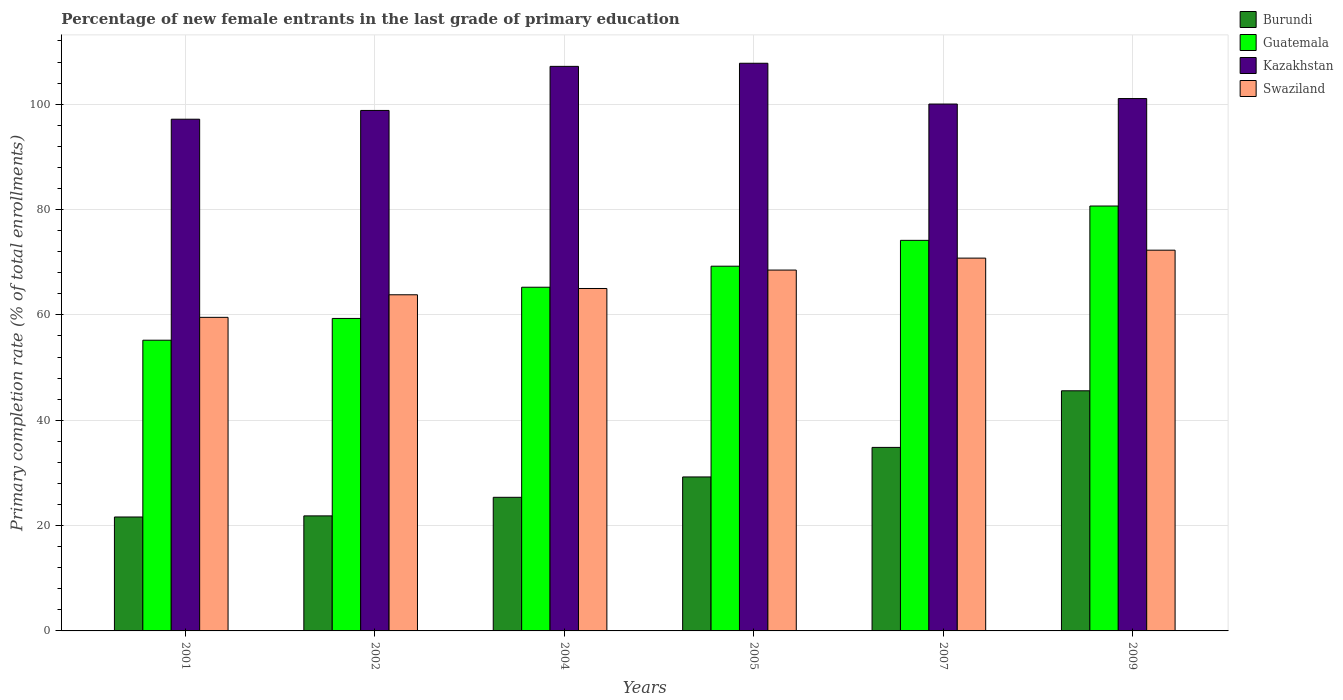How many different coloured bars are there?
Provide a succinct answer. 4. Are the number of bars per tick equal to the number of legend labels?
Your response must be concise. Yes. Are the number of bars on each tick of the X-axis equal?
Provide a succinct answer. Yes. How many bars are there on the 3rd tick from the left?
Your response must be concise. 4. How many bars are there on the 4th tick from the right?
Provide a succinct answer. 4. What is the percentage of new female entrants in Swaziland in 2007?
Offer a terse response. 70.77. Across all years, what is the maximum percentage of new female entrants in Guatemala?
Your answer should be compact. 80.66. Across all years, what is the minimum percentage of new female entrants in Swaziland?
Offer a very short reply. 59.53. In which year was the percentage of new female entrants in Kazakhstan maximum?
Ensure brevity in your answer.  2005. What is the total percentage of new female entrants in Kazakhstan in the graph?
Keep it short and to the point. 611.99. What is the difference between the percentage of new female entrants in Burundi in 2001 and that in 2002?
Make the answer very short. -0.21. What is the difference between the percentage of new female entrants in Burundi in 2005 and the percentage of new female entrants in Guatemala in 2009?
Make the answer very short. -51.43. What is the average percentage of new female entrants in Kazakhstan per year?
Offer a very short reply. 102. In the year 2007, what is the difference between the percentage of new female entrants in Swaziland and percentage of new female entrants in Burundi?
Keep it short and to the point. 35.93. What is the ratio of the percentage of new female entrants in Swaziland in 2004 to that in 2007?
Offer a terse response. 0.92. Is the percentage of new female entrants in Burundi in 2004 less than that in 2009?
Your answer should be compact. Yes. Is the difference between the percentage of new female entrants in Swaziland in 2004 and 2005 greater than the difference between the percentage of new female entrants in Burundi in 2004 and 2005?
Keep it short and to the point. Yes. What is the difference between the highest and the second highest percentage of new female entrants in Guatemala?
Give a very brief answer. 6.52. What is the difference between the highest and the lowest percentage of new female entrants in Swaziland?
Keep it short and to the point. 12.75. In how many years, is the percentage of new female entrants in Guatemala greater than the average percentage of new female entrants in Guatemala taken over all years?
Your answer should be very brief. 3. Is the sum of the percentage of new female entrants in Swaziland in 2001 and 2004 greater than the maximum percentage of new female entrants in Guatemala across all years?
Your answer should be very brief. Yes. What does the 1st bar from the left in 2002 represents?
Provide a succinct answer. Burundi. What does the 1st bar from the right in 2004 represents?
Make the answer very short. Swaziland. Is it the case that in every year, the sum of the percentage of new female entrants in Burundi and percentage of new female entrants in Swaziland is greater than the percentage of new female entrants in Guatemala?
Ensure brevity in your answer.  Yes. How many bars are there?
Ensure brevity in your answer.  24. Are all the bars in the graph horizontal?
Your answer should be compact. No. How many years are there in the graph?
Provide a short and direct response. 6. Are the values on the major ticks of Y-axis written in scientific E-notation?
Your response must be concise. No. Does the graph contain any zero values?
Your answer should be compact. No. Where does the legend appear in the graph?
Your answer should be compact. Top right. How many legend labels are there?
Keep it short and to the point. 4. What is the title of the graph?
Your answer should be compact. Percentage of new female entrants in the last grade of primary education. What is the label or title of the Y-axis?
Offer a very short reply. Primary completion rate (% of total enrollments). What is the Primary completion rate (% of total enrollments) in Burundi in 2001?
Offer a terse response. 21.63. What is the Primary completion rate (% of total enrollments) in Guatemala in 2001?
Offer a very short reply. 55.19. What is the Primary completion rate (% of total enrollments) in Kazakhstan in 2001?
Give a very brief answer. 97.15. What is the Primary completion rate (% of total enrollments) of Swaziland in 2001?
Keep it short and to the point. 59.53. What is the Primary completion rate (% of total enrollments) of Burundi in 2002?
Make the answer very short. 21.84. What is the Primary completion rate (% of total enrollments) of Guatemala in 2002?
Your answer should be very brief. 59.32. What is the Primary completion rate (% of total enrollments) of Kazakhstan in 2002?
Make the answer very short. 98.81. What is the Primary completion rate (% of total enrollments) in Swaziland in 2002?
Make the answer very short. 63.81. What is the Primary completion rate (% of total enrollments) in Burundi in 2004?
Offer a very short reply. 25.37. What is the Primary completion rate (% of total enrollments) of Guatemala in 2004?
Provide a succinct answer. 65.25. What is the Primary completion rate (% of total enrollments) in Kazakhstan in 2004?
Offer a very short reply. 107.18. What is the Primary completion rate (% of total enrollments) of Swaziland in 2004?
Ensure brevity in your answer.  65.01. What is the Primary completion rate (% of total enrollments) of Burundi in 2005?
Provide a short and direct response. 29.23. What is the Primary completion rate (% of total enrollments) of Guatemala in 2005?
Provide a short and direct response. 69.24. What is the Primary completion rate (% of total enrollments) in Kazakhstan in 2005?
Make the answer very short. 107.77. What is the Primary completion rate (% of total enrollments) in Swaziland in 2005?
Make the answer very short. 68.51. What is the Primary completion rate (% of total enrollments) in Burundi in 2007?
Give a very brief answer. 34.84. What is the Primary completion rate (% of total enrollments) of Guatemala in 2007?
Your response must be concise. 74.15. What is the Primary completion rate (% of total enrollments) of Kazakhstan in 2007?
Keep it short and to the point. 100.03. What is the Primary completion rate (% of total enrollments) of Swaziland in 2007?
Give a very brief answer. 70.77. What is the Primary completion rate (% of total enrollments) of Burundi in 2009?
Your answer should be compact. 45.59. What is the Primary completion rate (% of total enrollments) in Guatemala in 2009?
Your answer should be very brief. 80.66. What is the Primary completion rate (% of total enrollments) of Kazakhstan in 2009?
Your answer should be compact. 101.07. What is the Primary completion rate (% of total enrollments) in Swaziland in 2009?
Make the answer very short. 72.28. Across all years, what is the maximum Primary completion rate (% of total enrollments) of Burundi?
Your answer should be very brief. 45.59. Across all years, what is the maximum Primary completion rate (% of total enrollments) of Guatemala?
Offer a very short reply. 80.66. Across all years, what is the maximum Primary completion rate (% of total enrollments) of Kazakhstan?
Your answer should be very brief. 107.77. Across all years, what is the maximum Primary completion rate (% of total enrollments) of Swaziland?
Your answer should be very brief. 72.28. Across all years, what is the minimum Primary completion rate (% of total enrollments) of Burundi?
Keep it short and to the point. 21.63. Across all years, what is the minimum Primary completion rate (% of total enrollments) in Guatemala?
Provide a short and direct response. 55.19. Across all years, what is the minimum Primary completion rate (% of total enrollments) in Kazakhstan?
Ensure brevity in your answer.  97.15. Across all years, what is the minimum Primary completion rate (% of total enrollments) of Swaziland?
Ensure brevity in your answer.  59.53. What is the total Primary completion rate (% of total enrollments) in Burundi in the graph?
Offer a terse response. 178.5. What is the total Primary completion rate (% of total enrollments) in Guatemala in the graph?
Keep it short and to the point. 403.81. What is the total Primary completion rate (% of total enrollments) in Kazakhstan in the graph?
Provide a short and direct response. 611.99. What is the total Primary completion rate (% of total enrollments) of Swaziland in the graph?
Your answer should be very brief. 399.91. What is the difference between the Primary completion rate (% of total enrollments) in Burundi in 2001 and that in 2002?
Keep it short and to the point. -0.21. What is the difference between the Primary completion rate (% of total enrollments) of Guatemala in 2001 and that in 2002?
Your answer should be compact. -4.13. What is the difference between the Primary completion rate (% of total enrollments) in Kazakhstan in 2001 and that in 2002?
Your response must be concise. -1.66. What is the difference between the Primary completion rate (% of total enrollments) in Swaziland in 2001 and that in 2002?
Your answer should be very brief. -4.29. What is the difference between the Primary completion rate (% of total enrollments) of Burundi in 2001 and that in 2004?
Your response must be concise. -3.74. What is the difference between the Primary completion rate (% of total enrollments) of Guatemala in 2001 and that in 2004?
Offer a very short reply. -10.06. What is the difference between the Primary completion rate (% of total enrollments) in Kazakhstan in 2001 and that in 2004?
Give a very brief answer. -10.03. What is the difference between the Primary completion rate (% of total enrollments) in Swaziland in 2001 and that in 2004?
Provide a short and direct response. -5.48. What is the difference between the Primary completion rate (% of total enrollments) of Burundi in 2001 and that in 2005?
Give a very brief answer. -7.6. What is the difference between the Primary completion rate (% of total enrollments) of Guatemala in 2001 and that in 2005?
Make the answer very short. -14.05. What is the difference between the Primary completion rate (% of total enrollments) in Kazakhstan in 2001 and that in 2005?
Your response must be concise. -10.62. What is the difference between the Primary completion rate (% of total enrollments) in Swaziland in 2001 and that in 2005?
Keep it short and to the point. -8.98. What is the difference between the Primary completion rate (% of total enrollments) of Burundi in 2001 and that in 2007?
Provide a short and direct response. -13.21. What is the difference between the Primary completion rate (% of total enrollments) of Guatemala in 2001 and that in 2007?
Your response must be concise. -18.96. What is the difference between the Primary completion rate (% of total enrollments) of Kazakhstan in 2001 and that in 2007?
Keep it short and to the point. -2.88. What is the difference between the Primary completion rate (% of total enrollments) of Swaziland in 2001 and that in 2007?
Offer a very short reply. -11.25. What is the difference between the Primary completion rate (% of total enrollments) in Burundi in 2001 and that in 2009?
Offer a terse response. -23.96. What is the difference between the Primary completion rate (% of total enrollments) in Guatemala in 2001 and that in 2009?
Ensure brevity in your answer.  -25.47. What is the difference between the Primary completion rate (% of total enrollments) in Kazakhstan in 2001 and that in 2009?
Your answer should be compact. -3.92. What is the difference between the Primary completion rate (% of total enrollments) of Swaziland in 2001 and that in 2009?
Provide a short and direct response. -12.75. What is the difference between the Primary completion rate (% of total enrollments) in Burundi in 2002 and that in 2004?
Your response must be concise. -3.52. What is the difference between the Primary completion rate (% of total enrollments) of Guatemala in 2002 and that in 2004?
Provide a succinct answer. -5.93. What is the difference between the Primary completion rate (% of total enrollments) in Kazakhstan in 2002 and that in 2004?
Your response must be concise. -8.37. What is the difference between the Primary completion rate (% of total enrollments) of Swaziland in 2002 and that in 2004?
Your response must be concise. -1.19. What is the difference between the Primary completion rate (% of total enrollments) in Burundi in 2002 and that in 2005?
Your answer should be compact. -7.39. What is the difference between the Primary completion rate (% of total enrollments) in Guatemala in 2002 and that in 2005?
Make the answer very short. -9.92. What is the difference between the Primary completion rate (% of total enrollments) of Kazakhstan in 2002 and that in 2005?
Give a very brief answer. -8.96. What is the difference between the Primary completion rate (% of total enrollments) in Swaziland in 2002 and that in 2005?
Your answer should be compact. -4.69. What is the difference between the Primary completion rate (% of total enrollments) in Burundi in 2002 and that in 2007?
Make the answer very short. -13. What is the difference between the Primary completion rate (% of total enrollments) of Guatemala in 2002 and that in 2007?
Ensure brevity in your answer.  -14.83. What is the difference between the Primary completion rate (% of total enrollments) of Kazakhstan in 2002 and that in 2007?
Your answer should be very brief. -1.22. What is the difference between the Primary completion rate (% of total enrollments) of Swaziland in 2002 and that in 2007?
Your answer should be compact. -6.96. What is the difference between the Primary completion rate (% of total enrollments) in Burundi in 2002 and that in 2009?
Keep it short and to the point. -23.75. What is the difference between the Primary completion rate (% of total enrollments) of Guatemala in 2002 and that in 2009?
Your response must be concise. -21.34. What is the difference between the Primary completion rate (% of total enrollments) in Kazakhstan in 2002 and that in 2009?
Give a very brief answer. -2.26. What is the difference between the Primary completion rate (% of total enrollments) of Swaziland in 2002 and that in 2009?
Provide a short and direct response. -8.47. What is the difference between the Primary completion rate (% of total enrollments) of Burundi in 2004 and that in 2005?
Your answer should be compact. -3.87. What is the difference between the Primary completion rate (% of total enrollments) of Guatemala in 2004 and that in 2005?
Keep it short and to the point. -3.99. What is the difference between the Primary completion rate (% of total enrollments) of Kazakhstan in 2004 and that in 2005?
Your response must be concise. -0.59. What is the difference between the Primary completion rate (% of total enrollments) of Swaziland in 2004 and that in 2005?
Your response must be concise. -3.5. What is the difference between the Primary completion rate (% of total enrollments) of Burundi in 2004 and that in 2007?
Give a very brief answer. -9.47. What is the difference between the Primary completion rate (% of total enrollments) in Guatemala in 2004 and that in 2007?
Provide a succinct answer. -8.9. What is the difference between the Primary completion rate (% of total enrollments) in Kazakhstan in 2004 and that in 2007?
Make the answer very short. 7.15. What is the difference between the Primary completion rate (% of total enrollments) in Swaziland in 2004 and that in 2007?
Make the answer very short. -5.77. What is the difference between the Primary completion rate (% of total enrollments) of Burundi in 2004 and that in 2009?
Your answer should be compact. -20.22. What is the difference between the Primary completion rate (% of total enrollments) in Guatemala in 2004 and that in 2009?
Keep it short and to the point. -15.42. What is the difference between the Primary completion rate (% of total enrollments) of Kazakhstan in 2004 and that in 2009?
Keep it short and to the point. 6.11. What is the difference between the Primary completion rate (% of total enrollments) in Swaziland in 2004 and that in 2009?
Make the answer very short. -7.27. What is the difference between the Primary completion rate (% of total enrollments) in Burundi in 2005 and that in 2007?
Offer a terse response. -5.61. What is the difference between the Primary completion rate (% of total enrollments) in Guatemala in 2005 and that in 2007?
Offer a terse response. -4.91. What is the difference between the Primary completion rate (% of total enrollments) of Kazakhstan in 2005 and that in 2007?
Your response must be concise. 7.74. What is the difference between the Primary completion rate (% of total enrollments) of Swaziland in 2005 and that in 2007?
Your answer should be very brief. -2.27. What is the difference between the Primary completion rate (% of total enrollments) in Burundi in 2005 and that in 2009?
Your response must be concise. -16.36. What is the difference between the Primary completion rate (% of total enrollments) of Guatemala in 2005 and that in 2009?
Provide a succinct answer. -11.42. What is the difference between the Primary completion rate (% of total enrollments) of Kazakhstan in 2005 and that in 2009?
Provide a succinct answer. 6.7. What is the difference between the Primary completion rate (% of total enrollments) in Swaziland in 2005 and that in 2009?
Keep it short and to the point. -3.77. What is the difference between the Primary completion rate (% of total enrollments) in Burundi in 2007 and that in 2009?
Provide a succinct answer. -10.75. What is the difference between the Primary completion rate (% of total enrollments) of Guatemala in 2007 and that in 2009?
Make the answer very short. -6.52. What is the difference between the Primary completion rate (% of total enrollments) in Kazakhstan in 2007 and that in 2009?
Offer a very short reply. -1.04. What is the difference between the Primary completion rate (% of total enrollments) of Swaziland in 2007 and that in 2009?
Provide a short and direct response. -1.51. What is the difference between the Primary completion rate (% of total enrollments) in Burundi in 2001 and the Primary completion rate (% of total enrollments) in Guatemala in 2002?
Ensure brevity in your answer.  -37.69. What is the difference between the Primary completion rate (% of total enrollments) in Burundi in 2001 and the Primary completion rate (% of total enrollments) in Kazakhstan in 2002?
Make the answer very short. -77.18. What is the difference between the Primary completion rate (% of total enrollments) of Burundi in 2001 and the Primary completion rate (% of total enrollments) of Swaziland in 2002?
Offer a very short reply. -42.18. What is the difference between the Primary completion rate (% of total enrollments) of Guatemala in 2001 and the Primary completion rate (% of total enrollments) of Kazakhstan in 2002?
Provide a succinct answer. -43.62. What is the difference between the Primary completion rate (% of total enrollments) in Guatemala in 2001 and the Primary completion rate (% of total enrollments) in Swaziland in 2002?
Give a very brief answer. -8.62. What is the difference between the Primary completion rate (% of total enrollments) of Kazakhstan in 2001 and the Primary completion rate (% of total enrollments) of Swaziland in 2002?
Ensure brevity in your answer.  33.33. What is the difference between the Primary completion rate (% of total enrollments) of Burundi in 2001 and the Primary completion rate (% of total enrollments) of Guatemala in 2004?
Keep it short and to the point. -43.62. What is the difference between the Primary completion rate (% of total enrollments) of Burundi in 2001 and the Primary completion rate (% of total enrollments) of Kazakhstan in 2004?
Provide a short and direct response. -85.55. What is the difference between the Primary completion rate (% of total enrollments) in Burundi in 2001 and the Primary completion rate (% of total enrollments) in Swaziland in 2004?
Your response must be concise. -43.38. What is the difference between the Primary completion rate (% of total enrollments) in Guatemala in 2001 and the Primary completion rate (% of total enrollments) in Kazakhstan in 2004?
Ensure brevity in your answer.  -51.99. What is the difference between the Primary completion rate (% of total enrollments) of Guatemala in 2001 and the Primary completion rate (% of total enrollments) of Swaziland in 2004?
Offer a very short reply. -9.82. What is the difference between the Primary completion rate (% of total enrollments) in Kazakhstan in 2001 and the Primary completion rate (% of total enrollments) in Swaziland in 2004?
Your answer should be very brief. 32.14. What is the difference between the Primary completion rate (% of total enrollments) of Burundi in 2001 and the Primary completion rate (% of total enrollments) of Guatemala in 2005?
Provide a short and direct response. -47.61. What is the difference between the Primary completion rate (% of total enrollments) in Burundi in 2001 and the Primary completion rate (% of total enrollments) in Kazakhstan in 2005?
Make the answer very short. -86.14. What is the difference between the Primary completion rate (% of total enrollments) of Burundi in 2001 and the Primary completion rate (% of total enrollments) of Swaziland in 2005?
Give a very brief answer. -46.88. What is the difference between the Primary completion rate (% of total enrollments) of Guatemala in 2001 and the Primary completion rate (% of total enrollments) of Kazakhstan in 2005?
Offer a terse response. -52.58. What is the difference between the Primary completion rate (% of total enrollments) in Guatemala in 2001 and the Primary completion rate (% of total enrollments) in Swaziland in 2005?
Provide a succinct answer. -13.32. What is the difference between the Primary completion rate (% of total enrollments) in Kazakhstan in 2001 and the Primary completion rate (% of total enrollments) in Swaziland in 2005?
Make the answer very short. 28.64. What is the difference between the Primary completion rate (% of total enrollments) of Burundi in 2001 and the Primary completion rate (% of total enrollments) of Guatemala in 2007?
Make the answer very short. -52.52. What is the difference between the Primary completion rate (% of total enrollments) in Burundi in 2001 and the Primary completion rate (% of total enrollments) in Kazakhstan in 2007?
Keep it short and to the point. -78.4. What is the difference between the Primary completion rate (% of total enrollments) in Burundi in 2001 and the Primary completion rate (% of total enrollments) in Swaziland in 2007?
Provide a short and direct response. -49.14. What is the difference between the Primary completion rate (% of total enrollments) of Guatemala in 2001 and the Primary completion rate (% of total enrollments) of Kazakhstan in 2007?
Ensure brevity in your answer.  -44.83. What is the difference between the Primary completion rate (% of total enrollments) in Guatemala in 2001 and the Primary completion rate (% of total enrollments) in Swaziland in 2007?
Your answer should be very brief. -15.58. What is the difference between the Primary completion rate (% of total enrollments) of Kazakhstan in 2001 and the Primary completion rate (% of total enrollments) of Swaziland in 2007?
Offer a very short reply. 26.37. What is the difference between the Primary completion rate (% of total enrollments) of Burundi in 2001 and the Primary completion rate (% of total enrollments) of Guatemala in 2009?
Your response must be concise. -59.03. What is the difference between the Primary completion rate (% of total enrollments) in Burundi in 2001 and the Primary completion rate (% of total enrollments) in Kazakhstan in 2009?
Your answer should be very brief. -79.44. What is the difference between the Primary completion rate (% of total enrollments) in Burundi in 2001 and the Primary completion rate (% of total enrollments) in Swaziland in 2009?
Provide a succinct answer. -50.65. What is the difference between the Primary completion rate (% of total enrollments) of Guatemala in 2001 and the Primary completion rate (% of total enrollments) of Kazakhstan in 2009?
Give a very brief answer. -45.88. What is the difference between the Primary completion rate (% of total enrollments) in Guatemala in 2001 and the Primary completion rate (% of total enrollments) in Swaziland in 2009?
Make the answer very short. -17.09. What is the difference between the Primary completion rate (% of total enrollments) in Kazakhstan in 2001 and the Primary completion rate (% of total enrollments) in Swaziland in 2009?
Your answer should be very brief. 24.86. What is the difference between the Primary completion rate (% of total enrollments) in Burundi in 2002 and the Primary completion rate (% of total enrollments) in Guatemala in 2004?
Offer a very short reply. -43.41. What is the difference between the Primary completion rate (% of total enrollments) of Burundi in 2002 and the Primary completion rate (% of total enrollments) of Kazakhstan in 2004?
Offer a very short reply. -85.34. What is the difference between the Primary completion rate (% of total enrollments) of Burundi in 2002 and the Primary completion rate (% of total enrollments) of Swaziland in 2004?
Make the answer very short. -43.17. What is the difference between the Primary completion rate (% of total enrollments) in Guatemala in 2002 and the Primary completion rate (% of total enrollments) in Kazakhstan in 2004?
Your answer should be compact. -47.86. What is the difference between the Primary completion rate (% of total enrollments) of Guatemala in 2002 and the Primary completion rate (% of total enrollments) of Swaziland in 2004?
Your answer should be very brief. -5.69. What is the difference between the Primary completion rate (% of total enrollments) in Kazakhstan in 2002 and the Primary completion rate (% of total enrollments) in Swaziland in 2004?
Provide a succinct answer. 33.8. What is the difference between the Primary completion rate (% of total enrollments) of Burundi in 2002 and the Primary completion rate (% of total enrollments) of Guatemala in 2005?
Keep it short and to the point. -47.4. What is the difference between the Primary completion rate (% of total enrollments) in Burundi in 2002 and the Primary completion rate (% of total enrollments) in Kazakhstan in 2005?
Provide a succinct answer. -85.93. What is the difference between the Primary completion rate (% of total enrollments) of Burundi in 2002 and the Primary completion rate (% of total enrollments) of Swaziland in 2005?
Give a very brief answer. -46.67. What is the difference between the Primary completion rate (% of total enrollments) in Guatemala in 2002 and the Primary completion rate (% of total enrollments) in Kazakhstan in 2005?
Your answer should be very brief. -48.45. What is the difference between the Primary completion rate (% of total enrollments) of Guatemala in 2002 and the Primary completion rate (% of total enrollments) of Swaziland in 2005?
Your answer should be compact. -9.19. What is the difference between the Primary completion rate (% of total enrollments) of Kazakhstan in 2002 and the Primary completion rate (% of total enrollments) of Swaziland in 2005?
Your answer should be compact. 30.3. What is the difference between the Primary completion rate (% of total enrollments) of Burundi in 2002 and the Primary completion rate (% of total enrollments) of Guatemala in 2007?
Make the answer very short. -52.31. What is the difference between the Primary completion rate (% of total enrollments) of Burundi in 2002 and the Primary completion rate (% of total enrollments) of Kazakhstan in 2007?
Offer a terse response. -78.19. What is the difference between the Primary completion rate (% of total enrollments) in Burundi in 2002 and the Primary completion rate (% of total enrollments) in Swaziland in 2007?
Make the answer very short. -48.93. What is the difference between the Primary completion rate (% of total enrollments) of Guatemala in 2002 and the Primary completion rate (% of total enrollments) of Kazakhstan in 2007?
Provide a short and direct response. -40.7. What is the difference between the Primary completion rate (% of total enrollments) of Guatemala in 2002 and the Primary completion rate (% of total enrollments) of Swaziland in 2007?
Provide a short and direct response. -11.45. What is the difference between the Primary completion rate (% of total enrollments) in Kazakhstan in 2002 and the Primary completion rate (% of total enrollments) in Swaziland in 2007?
Your answer should be very brief. 28.04. What is the difference between the Primary completion rate (% of total enrollments) in Burundi in 2002 and the Primary completion rate (% of total enrollments) in Guatemala in 2009?
Offer a very short reply. -58.82. What is the difference between the Primary completion rate (% of total enrollments) of Burundi in 2002 and the Primary completion rate (% of total enrollments) of Kazakhstan in 2009?
Ensure brevity in your answer.  -79.23. What is the difference between the Primary completion rate (% of total enrollments) of Burundi in 2002 and the Primary completion rate (% of total enrollments) of Swaziland in 2009?
Ensure brevity in your answer.  -50.44. What is the difference between the Primary completion rate (% of total enrollments) of Guatemala in 2002 and the Primary completion rate (% of total enrollments) of Kazakhstan in 2009?
Offer a very short reply. -41.75. What is the difference between the Primary completion rate (% of total enrollments) in Guatemala in 2002 and the Primary completion rate (% of total enrollments) in Swaziland in 2009?
Give a very brief answer. -12.96. What is the difference between the Primary completion rate (% of total enrollments) of Kazakhstan in 2002 and the Primary completion rate (% of total enrollments) of Swaziland in 2009?
Your response must be concise. 26.53. What is the difference between the Primary completion rate (% of total enrollments) of Burundi in 2004 and the Primary completion rate (% of total enrollments) of Guatemala in 2005?
Offer a terse response. -43.88. What is the difference between the Primary completion rate (% of total enrollments) in Burundi in 2004 and the Primary completion rate (% of total enrollments) in Kazakhstan in 2005?
Give a very brief answer. -82.4. What is the difference between the Primary completion rate (% of total enrollments) in Burundi in 2004 and the Primary completion rate (% of total enrollments) in Swaziland in 2005?
Ensure brevity in your answer.  -43.14. What is the difference between the Primary completion rate (% of total enrollments) of Guatemala in 2004 and the Primary completion rate (% of total enrollments) of Kazakhstan in 2005?
Keep it short and to the point. -42.52. What is the difference between the Primary completion rate (% of total enrollments) of Guatemala in 2004 and the Primary completion rate (% of total enrollments) of Swaziland in 2005?
Give a very brief answer. -3.26. What is the difference between the Primary completion rate (% of total enrollments) of Kazakhstan in 2004 and the Primary completion rate (% of total enrollments) of Swaziland in 2005?
Offer a very short reply. 38.67. What is the difference between the Primary completion rate (% of total enrollments) in Burundi in 2004 and the Primary completion rate (% of total enrollments) in Guatemala in 2007?
Your response must be concise. -48.78. What is the difference between the Primary completion rate (% of total enrollments) of Burundi in 2004 and the Primary completion rate (% of total enrollments) of Kazakhstan in 2007?
Offer a very short reply. -74.66. What is the difference between the Primary completion rate (% of total enrollments) in Burundi in 2004 and the Primary completion rate (% of total enrollments) in Swaziland in 2007?
Keep it short and to the point. -45.41. What is the difference between the Primary completion rate (% of total enrollments) in Guatemala in 2004 and the Primary completion rate (% of total enrollments) in Kazakhstan in 2007?
Offer a very short reply. -34.78. What is the difference between the Primary completion rate (% of total enrollments) in Guatemala in 2004 and the Primary completion rate (% of total enrollments) in Swaziland in 2007?
Make the answer very short. -5.52. What is the difference between the Primary completion rate (% of total enrollments) of Kazakhstan in 2004 and the Primary completion rate (% of total enrollments) of Swaziland in 2007?
Your answer should be compact. 36.4. What is the difference between the Primary completion rate (% of total enrollments) in Burundi in 2004 and the Primary completion rate (% of total enrollments) in Guatemala in 2009?
Provide a short and direct response. -55.3. What is the difference between the Primary completion rate (% of total enrollments) in Burundi in 2004 and the Primary completion rate (% of total enrollments) in Kazakhstan in 2009?
Provide a succinct answer. -75.7. What is the difference between the Primary completion rate (% of total enrollments) of Burundi in 2004 and the Primary completion rate (% of total enrollments) of Swaziland in 2009?
Provide a short and direct response. -46.92. What is the difference between the Primary completion rate (% of total enrollments) of Guatemala in 2004 and the Primary completion rate (% of total enrollments) of Kazakhstan in 2009?
Ensure brevity in your answer.  -35.82. What is the difference between the Primary completion rate (% of total enrollments) in Guatemala in 2004 and the Primary completion rate (% of total enrollments) in Swaziland in 2009?
Provide a short and direct response. -7.03. What is the difference between the Primary completion rate (% of total enrollments) in Kazakhstan in 2004 and the Primary completion rate (% of total enrollments) in Swaziland in 2009?
Keep it short and to the point. 34.9. What is the difference between the Primary completion rate (% of total enrollments) in Burundi in 2005 and the Primary completion rate (% of total enrollments) in Guatemala in 2007?
Keep it short and to the point. -44.92. What is the difference between the Primary completion rate (% of total enrollments) of Burundi in 2005 and the Primary completion rate (% of total enrollments) of Kazakhstan in 2007?
Provide a succinct answer. -70.79. What is the difference between the Primary completion rate (% of total enrollments) of Burundi in 2005 and the Primary completion rate (% of total enrollments) of Swaziland in 2007?
Your response must be concise. -41.54. What is the difference between the Primary completion rate (% of total enrollments) of Guatemala in 2005 and the Primary completion rate (% of total enrollments) of Kazakhstan in 2007?
Keep it short and to the point. -30.78. What is the difference between the Primary completion rate (% of total enrollments) of Guatemala in 2005 and the Primary completion rate (% of total enrollments) of Swaziland in 2007?
Your response must be concise. -1.53. What is the difference between the Primary completion rate (% of total enrollments) in Kazakhstan in 2005 and the Primary completion rate (% of total enrollments) in Swaziland in 2007?
Provide a succinct answer. 36.99. What is the difference between the Primary completion rate (% of total enrollments) of Burundi in 2005 and the Primary completion rate (% of total enrollments) of Guatemala in 2009?
Offer a terse response. -51.43. What is the difference between the Primary completion rate (% of total enrollments) in Burundi in 2005 and the Primary completion rate (% of total enrollments) in Kazakhstan in 2009?
Provide a short and direct response. -71.84. What is the difference between the Primary completion rate (% of total enrollments) of Burundi in 2005 and the Primary completion rate (% of total enrollments) of Swaziland in 2009?
Your answer should be very brief. -43.05. What is the difference between the Primary completion rate (% of total enrollments) of Guatemala in 2005 and the Primary completion rate (% of total enrollments) of Kazakhstan in 2009?
Give a very brief answer. -31.83. What is the difference between the Primary completion rate (% of total enrollments) in Guatemala in 2005 and the Primary completion rate (% of total enrollments) in Swaziland in 2009?
Ensure brevity in your answer.  -3.04. What is the difference between the Primary completion rate (% of total enrollments) in Kazakhstan in 2005 and the Primary completion rate (% of total enrollments) in Swaziland in 2009?
Give a very brief answer. 35.49. What is the difference between the Primary completion rate (% of total enrollments) of Burundi in 2007 and the Primary completion rate (% of total enrollments) of Guatemala in 2009?
Your answer should be compact. -45.82. What is the difference between the Primary completion rate (% of total enrollments) of Burundi in 2007 and the Primary completion rate (% of total enrollments) of Kazakhstan in 2009?
Your response must be concise. -66.23. What is the difference between the Primary completion rate (% of total enrollments) of Burundi in 2007 and the Primary completion rate (% of total enrollments) of Swaziland in 2009?
Offer a terse response. -37.44. What is the difference between the Primary completion rate (% of total enrollments) of Guatemala in 2007 and the Primary completion rate (% of total enrollments) of Kazakhstan in 2009?
Your answer should be compact. -26.92. What is the difference between the Primary completion rate (% of total enrollments) of Guatemala in 2007 and the Primary completion rate (% of total enrollments) of Swaziland in 2009?
Your answer should be compact. 1.87. What is the difference between the Primary completion rate (% of total enrollments) in Kazakhstan in 2007 and the Primary completion rate (% of total enrollments) in Swaziland in 2009?
Provide a succinct answer. 27.74. What is the average Primary completion rate (% of total enrollments) of Burundi per year?
Your answer should be compact. 29.75. What is the average Primary completion rate (% of total enrollments) of Guatemala per year?
Provide a short and direct response. 67.3. What is the average Primary completion rate (% of total enrollments) in Kazakhstan per year?
Provide a succinct answer. 102. What is the average Primary completion rate (% of total enrollments) of Swaziland per year?
Ensure brevity in your answer.  66.65. In the year 2001, what is the difference between the Primary completion rate (% of total enrollments) in Burundi and Primary completion rate (% of total enrollments) in Guatemala?
Your answer should be compact. -33.56. In the year 2001, what is the difference between the Primary completion rate (% of total enrollments) of Burundi and Primary completion rate (% of total enrollments) of Kazakhstan?
Keep it short and to the point. -75.52. In the year 2001, what is the difference between the Primary completion rate (% of total enrollments) of Burundi and Primary completion rate (% of total enrollments) of Swaziland?
Ensure brevity in your answer.  -37.9. In the year 2001, what is the difference between the Primary completion rate (% of total enrollments) of Guatemala and Primary completion rate (% of total enrollments) of Kazakhstan?
Offer a very short reply. -41.96. In the year 2001, what is the difference between the Primary completion rate (% of total enrollments) of Guatemala and Primary completion rate (% of total enrollments) of Swaziland?
Offer a terse response. -4.34. In the year 2001, what is the difference between the Primary completion rate (% of total enrollments) of Kazakhstan and Primary completion rate (% of total enrollments) of Swaziland?
Offer a terse response. 37.62. In the year 2002, what is the difference between the Primary completion rate (% of total enrollments) in Burundi and Primary completion rate (% of total enrollments) in Guatemala?
Provide a succinct answer. -37.48. In the year 2002, what is the difference between the Primary completion rate (% of total enrollments) of Burundi and Primary completion rate (% of total enrollments) of Kazakhstan?
Make the answer very short. -76.97. In the year 2002, what is the difference between the Primary completion rate (% of total enrollments) in Burundi and Primary completion rate (% of total enrollments) in Swaziland?
Offer a terse response. -41.97. In the year 2002, what is the difference between the Primary completion rate (% of total enrollments) of Guatemala and Primary completion rate (% of total enrollments) of Kazakhstan?
Ensure brevity in your answer.  -39.49. In the year 2002, what is the difference between the Primary completion rate (% of total enrollments) in Guatemala and Primary completion rate (% of total enrollments) in Swaziland?
Your response must be concise. -4.49. In the year 2002, what is the difference between the Primary completion rate (% of total enrollments) of Kazakhstan and Primary completion rate (% of total enrollments) of Swaziland?
Give a very brief answer. 34.99. In the year 2004, what is the difference between the Primary completion rate (% of total enrollments) in Burundi and Primary completion rate (% of total enrollments) in Guatemala?
Offer a very short reply. -39.88. In the year 2004, what is the difference between the Primary completion rate (% of total enrollments) of Burundi and Primary completion rate (% of total enrollments) of Kazakhstan?
Offer a very short reply. -81.81. In the year 2004, what is the difference between the Primary completion rate (% of total enrollments) in Burundi and Primary completion rate (% of total enrollments) in Swaziland?
Your response must be concise. -39.64. In the year 2004, what is the difference between the Primary completion rate (% of total enrollments) of Guatemala and Primary completion rate (% of total enrollments) of Kazakhstan?
Your answer should be very brief. -41.93. In the year 2004, what is the difference between the Primary completion rate (% of total enrollments) of Guatemala and Primary completion rate (% of total enrollments) of Swaziland?
Provide a succinct answer. 0.24. In the year 2004, what is the difference between the Primary completion rate (% of total enrollments) in Kazakhstan and Primary completion rate (% of total enrollments) in Swaziland?
Your answer should be very brief. 42.17. In the year 2005, what is the difference between the Primary completion rate (% of total enrollments) of Burundi and Primary completion rate (% of total enrollments) of Guatemala?
Make the answer very short. -40.01. In the year 2005, what is the difference between the Primary completion rate (% of total enrollments) in Burundi and Primary completion rate (% of total enrollments) in Kazakhstan?
Give a very brief answer. -78.54. In the year 2005, what is the difference between the Primary completion rate (% of total enrollments) of Burundi and Primary completion rate (% of total enrollments) of Swaziland?
Your answer should be very brief. -39.28. In the year 2005, what is the difference between the Primary completion rate (% of total enrollments) of Guatemala and Primary completion rate (% of total enrollments) of Kazakhstan?
Your answer should be compact. -38.53. In the year 2005, what is the difference between the Primary completion rate (% of total enrollments) of Guatemala and Primary completion rate (% of total enrollments) of Swaziland?
Ensure brevity in your answer.  0.73. In the year 2005, what is the difference between the Primary completion rate (% of total enrollments) of Kazakhstan and Primary completion rate (% of total enrollments) of Swaziland?
Make the answer very short. 39.26. In the year 2007, what is the difference between the Primary completion rate (% of total enrollments) in Burundi and Primary completion rate (% of total enrollments) in Guatemala?
Offer a very short reply. -39.31. In the year 2007, what is the difference between the Primary completion rate (% of total enrollments) of Burundi and Primary completion rate (% of total enrollments) of Kazakhstan?
Offer a very short reply. -65.19. In the year 2007, what is the difference between the Primary completion rate (% of total enrollments) of Burundi and Primary completion rate (% of total enrollments) of Swaziland?
Keep it short and to the point. -35.93. In the year 2007, what is the difference between the Primary completion rate (% of total enrollments) in Guatemala and Primary completion rate (% of total enrollments) in Kazakhstan?
Your answer should be very brief. -25.88. In the year 2007, what is the difference between the Primary completion rate (% of total enrollments) in Guatemala and Primary completion rate (% of total enrollments) in Swaziland?
Keep it short and to the point. 3.37. In the year 2007, what is the difference between the Primary completion rate (% of total enrollments) in Kazakhstan and Primary completion rate (% of total enrollments) in Swaziland?
Ensure brevity in your answer.  29.25. In the year 2009, what is the difference between the Primary completion rate (% of total enrollments) of Burundi and Primary completion rate (% of total enrollments) of Guatemala?
Provide a succinct answer. -35.08. In the year 2009, what is the difference between the Primary completion rate (% of total enrollments) in Burundi and Primary completion rate (% of total enrollments) in Kazakhstan?
Offer a very short reply. -55.48. In the year 2009, what is the difference between the Primary completion rate (% of total enrollments) of Burundi and Primary completion rate (% of total enrollments) of Swaziland?
Ensure brevity in your answer.  -26.69. In the year 2009, what is the difference between the Primary completion rate (% of total enrollments) of Guatemala and Primary completion rate (% of total enrollments) of Kazakhstan?
Give a very brief answer. -20.4. In the year 2009, what is the difference between the Primary completion rate (% of total enrollments) of Guatemala and Primary completion rate (% of total enrollments) of Swaziland?
Give a very brief answer. 8.38. In the year 2009, what is the difference between the Primary completion rate (% of total enrollments) in Kazakhstan and Primary completion rate (% of total enrollments) in Swaziland?
Provide a succinct answer. 28.79. What is the ratio of the Primary completion rate (% of total enrollments) in Guatemala in 2001 to that in 2002?
Give a very brief answer. 0.93. What is the ratio of the Primary completion rate (% of total enrollments) in Kazakhstan in 2001 to that in 2002?
Ensure brevity in your answer.  0.98. What is the ratio of the Primary completion rate (% of total enrollments) in Swaziland in 2001 to that in 2002?
Your response must be concise. 0.93. What is the ratio of the Primary completion rate (% of total enrollments) of Burundi in 2001 to that in 2004?
Keep it short and to the point. 0.85. What is the ratio of the Primary completion rate (% of total enrollments) in Guatemala in 2001 to that in 2004?
Offer a terse response. 0.85. What is the ratio of the Primary completion rate (% of total enrollments) of Kazakhstan in 2001 to that in 2004?
Provide a short and direct response. 0.91. What is the ratio of the Primary completion rate (% of total enrollments) in Swaziland in 2001 to that in 2004?
Provide a succinct answer. 0.92. What is the ratio of the Primary completion rate (% of total enrollments) in Burundi in 2001 to that in 2005?
Offer a very short reply. 0.74. What is the ratio of the Primary completion rate (% of total enrollments) of Guatemala in 2001 to that in 2005?
Make the answer very short. 0.8. What is the ratio of the Primary completion rate (% of total enrollments) in Kazakhstan in 2001 to that in 2005?
Your answer should be compact. 0.9. What is the ratio of the Primary completion rate (% of total enrollments) of Swaziland in 2001 to that in 2005?
Offer a very short reply. 0.87. What is the ratio of the Primary completion rate (% of total enrollments) in Burundi in 2001 to that in 2007?
Provide a succinct answer. 0.62. What is the ratio of the Primary completion rate (% of total enrollments) of Guatemala in 2001 to that in 2007?
Your response must be concise. 0.74. What is the ratio of the Primary completion rate (% of total enrollments) in Kazakhstan in 2001 to that in 2007?
Ensure brevity in your answer.  0.97. What is the ratio of the Primary completion rate (% of total enrollments) in Swaziland in 2001 to that in 2007?
Your response must be concise. 0.84. What is the ratio of the Primary completion rate (% of total enrollments) in Burundi in 2001 to that in 2009?
Keep it short and to the point. 0.47. What is the ratio of the Primary completion rate (% of total enrollments) of Guatemala in 2001 to that in 2009?
Your response must be concise. 0.68. What is the ratio of the Primary completion rate (% of total enrollments) in Kazakhstan in 2001 to that in 2009?
Offer a very short reply. 0.96. What is the ratio of the Primary completion rate (% of total enrollments) in Swaziland in 2001 to that in 2009?
Keep it short and to the point. 0.82. What is the ratio of the Primary completion rate (% of total enrollments) in Burundi in 2002 to that in 2004?
Your answer should be very brief. 0.86. What is the ratio of the Primary completion rate (% of total enrollments) of Kazakhstan in 2002 to that in 2004?
Provide a succinct answer. 0.92. What is the ratio of the Primary completion rate (% of total enrollments) in Swaziland in 2002 to that in 2004?
Make the answer very short. 0.98. What is the ratio of the Primary completion rate (% of total enrollments) of Burundi in 2002 to that in 2005?
Your answer should be compact. 0.75. What is the ratio of the Primary completion rate (% of total enrollments) in Guatemala in 2002 to that in 2005?
Give a very brief answer. 0.86. What is the ratio of the Primary completion rate (% of total enrollments) of Kazakhstan in 2002 to that in 2005?
Provide a succinct answer. 0.92. What is the ratio of the Primary completion rate (% of total enrollments) in Swaziland in 2002 to that in 2005?
Make the answer very short. 0.93. What is the ratio of the Primary completion rate (% of total enrollments) in Burundi in 2002 to that in 2007?
Your answer should be very brief. 0.63. What is the ratio of the Primary completion rate (% of total enrollments) in Kazakhstan in 2002 to that in 2007?
Give a very brief answer. 0.99. What is the ratio of the Primary completion rate (% of total enrollments) of Swaziland in 2002 to that in 2007?
Your answer should be compact. 0.9. What is the ratio of the Primary completion rate (% of total enrollments) in Burundi in 2002 to that in 2009?
Offer a very short reply. 0.48. What is the ratio of the Primary completion rate (% of total enrollments) in Guatemala in 2002 to that in 2009?
Make the answer very short. 0.74. What is the ratio of the Primary completion rate (% of total enrollments) in Kazakhstan in 2002 to that in 2009?
Keep it short and to the point. 0.98. What is the ratio of the Primary completion rate (% of total enrollments) in Swaziland in 2002 to that in 2009?
Provide a short and direct response. 0.88. What is the ratio of the Primary completion rate (% of total enrollments) in Burundi in 2004 to that in 2005?
Your answer should be compact. 0.87. What is the ratio of the Primary completion rate (% of total enrollments) of Guatemala in 2004 to that in 2005?
Give a very brief answer. 0.94. What is the ratio of the Primary completion rate (% of total enrollments) in Swaziland in 2004 to that in 2005?
Your answer should be compact. 0.95. What is the ratio of the Primary completion rate (% of total enrollments) of Burundi in 2004 to that in 2007?
Give a very brief answer. 0.73. What is the ratio of the Primary completion rate (% of total enrollments) of Kazakhstan in 2004 to that in 2007?
Your answer should be very brief. 1.07. What is the ratio of the Primary completion rate (% of total enrollments) in Swaziland in 2004 to that in 2007?
Make the answer very short. 0.92. What is the ratio of the Primary completion rate (% of total enrollments) in Burundi in 2004 to that in 2009?
Ensure brevity in your answer.  0.56. What is the ratio of the Primary completion rate (% of total enrollments) of Guatemala in 2004 to that in 2009?
Make the answer very short. 0.81. What is the ratio of the Primary completion rate (% of total enrollments) in Kazakhstan in 2004 to that in 2009?
Offer a very short reply. 1.06. What is the ratio of the Primary completion rate (% of total enrollments) of Swaziland in 2004 to that in 2009?
Your answer should be compact. 0.9. What is the ratio of the Primary completion rate (% of total enrollments) of Burundi in 2005 to that in 2007?
Provide a succinct answer. 0.84. What is the ratio of the Primary completion rate (% of total enrollments) of Guatemala in 2005 to that in 2007?
Provide a succinct answer. 0.93. What is the ratio of the Primary completion rate (% of total enrollments) of Kazakhstan in 2005 to that in 2007?
Provide a succinct answer. 1.08. What is the ratio of the Primary completion rate (% of total enrollments) of Burundi in 2005 to that in 2009?
Give a very brief answer. 0.64. What is the ratio of the Primary completion rate (% of total enrollments) of Guatemala in 2005 to that in 2009?
Offer a terse response. 0.86. What is the ratio of the Primary completion rate (% of total enrollments) of Kazakhstan in 2005 to that in 2009?
Provide a short and direct response. 1.07. What is the ratio of the Primary completion rate (% of total enrollments) in Swaziland in 2005 to that in 2009?
Provide a succinct answer. 0.95. What is the ratio of the Primary completion rate (% of total enrollments) of Burundi in 2007 to that in 2009?
Your answer should be compact. 0.76. What is the ratio of the Primary completion rate (% of total enrollments) in Guatemala in 2007 to that in 2009?
Keep it short and to the point. 0.92. What is the ratio of the Primary completion rate (% of total enrollments) of Swaziland in 2007 to that in 2009?
Offer a terse response. 0.98. What is the difference between the highest and the second highest Primary completion rate (% of total enrollments) of Burundi?
Provide a short and direct response. 10.75. What is the difference between the highest and the second highest Primary completion rate (% of total enrollments) of Guatemala?
Ensure brevity in your answer.  6.52. What is the difference between the highest and the second highest Primary completion rate (% of total enrollments) of Kazakhstan?
Provide a short and direct response. 0.59. What is the difference between the highest and the second highest Primary completion rate (% of total enrollments) of Swaziland?
Provide a short and direct response. 1.51. What is the difference between the highest and the lowest Primary completion rate (% of total enrollments) in Burundi?
Your answer should be compact. 23.96. What is the difference between the highest and the lowest Primary completion rate (% of total enrollments) of Guatemala?
Offer a very short reply. 25.47. What is the difference between the highest and the lowest Primary completion rate (% of total enrollments) of Kazakhstan?
Ensure brevity in your answer.  10.62. What is the difference between the highest and the lowest Primary completion rate (% of total enrollments) of Swaziland?
Your response must be concise. 12.75. 